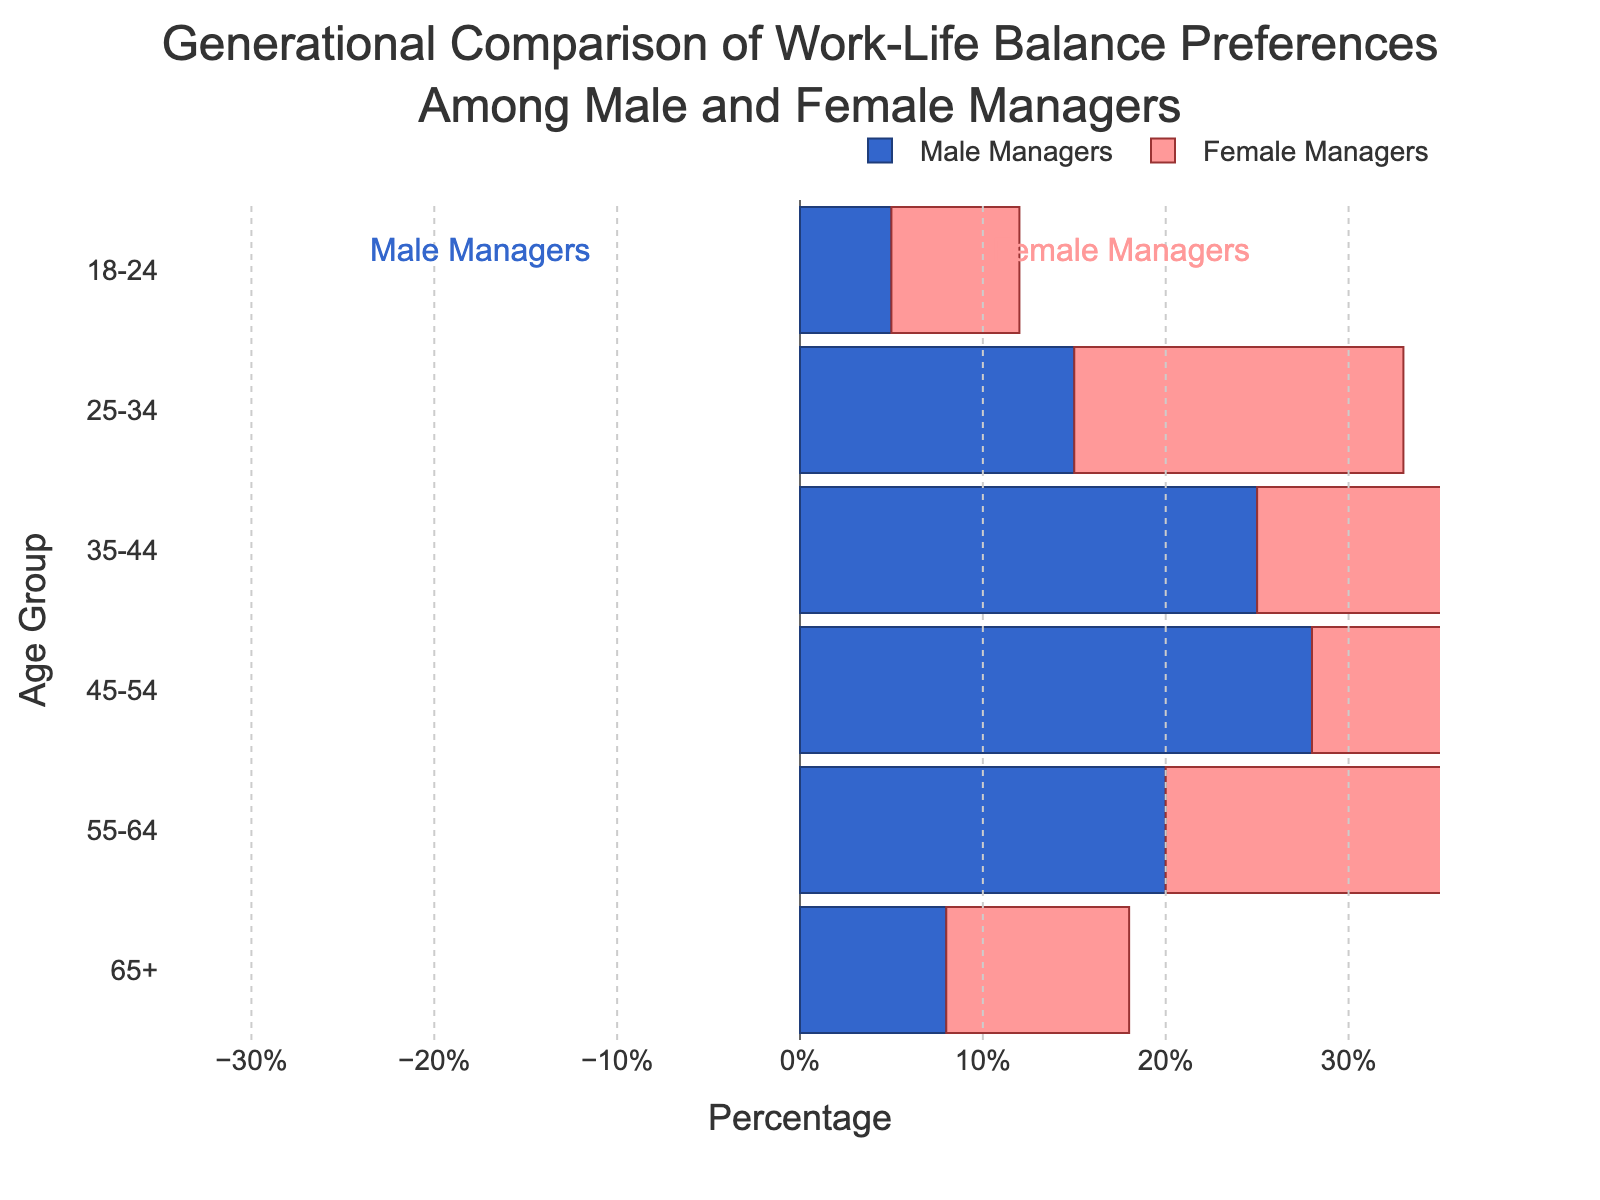What is the title of the figure? The title is located at the top of the figure and reads: "Generational Comparison of Work-Life Balance Preferences Among Male and Female Managers"
Answer: Generational Comparison of Work-Life Balance Preferences Among Male and Female Managers How many age groups are displayed in the figure? By counting the distinct strings along the y-axis, we can determine that there are six age groups: "18-24", "25-34", "35-44", "45-54", "55-64", and "65+"
Answer: Six Which age group has the highest percentage of female managers? By visually scanning the right side of the pyramid, we can see that the "45-54" age group has the longest bar, indicating the highest percentage of female managers
Answer: 45-54 Which age group has the highest percentage of male managers? By looking at the left side of the pyramid, the "45-54" age group has the longest bar, indicating the highest percentage of male managers
Answer: 45-54 What is the percentage difference between male and female managers in the 35-44 age group? The percentage of female managers is 30%, and for male managers, it is 25%. The difference can be calculated as 30% - 25% = 5%
Answer: 5% In which age group is the difference between male and female managers the smallest? By inspecting each age group's bars and calculating the difference, we find that the smallest difference is in the "18-24" age group, where the values are 7% for females and 5% for males, resulting in a 2% difference
Answer: 18-24 Is the percentage of male managers in the "55-64" age group higher or lower than the percentage of female managers in the same age group? We compare the values: male managers are represented by 20%, and female managers by 22%. Since 22% is greater than 20%, male managers' percentage is lower
Answer: Lower What is the combined percentage of male and female managers in the "65+" age group? We sum the absolute values of male and female managers' percentages: 8% (male) + 10% (female) = 18%
Answer: 18% Which gender has a higher percentage of managers in all age groups? By visually inspecting the lengths of the bars on each side of the pyramid in every age group, we notice that female managers consistently have longer bars. Hence, female managers have a higher percentage across all age groups
Answer: Female In the 25-34 age group, by how much does the percentage of female managers exceed that of male managers? The percentage of female managers is 18%, and the percentage of male managers is 15%. The excess is calculated as 18% - 15% = 3%
Answer: 3% 